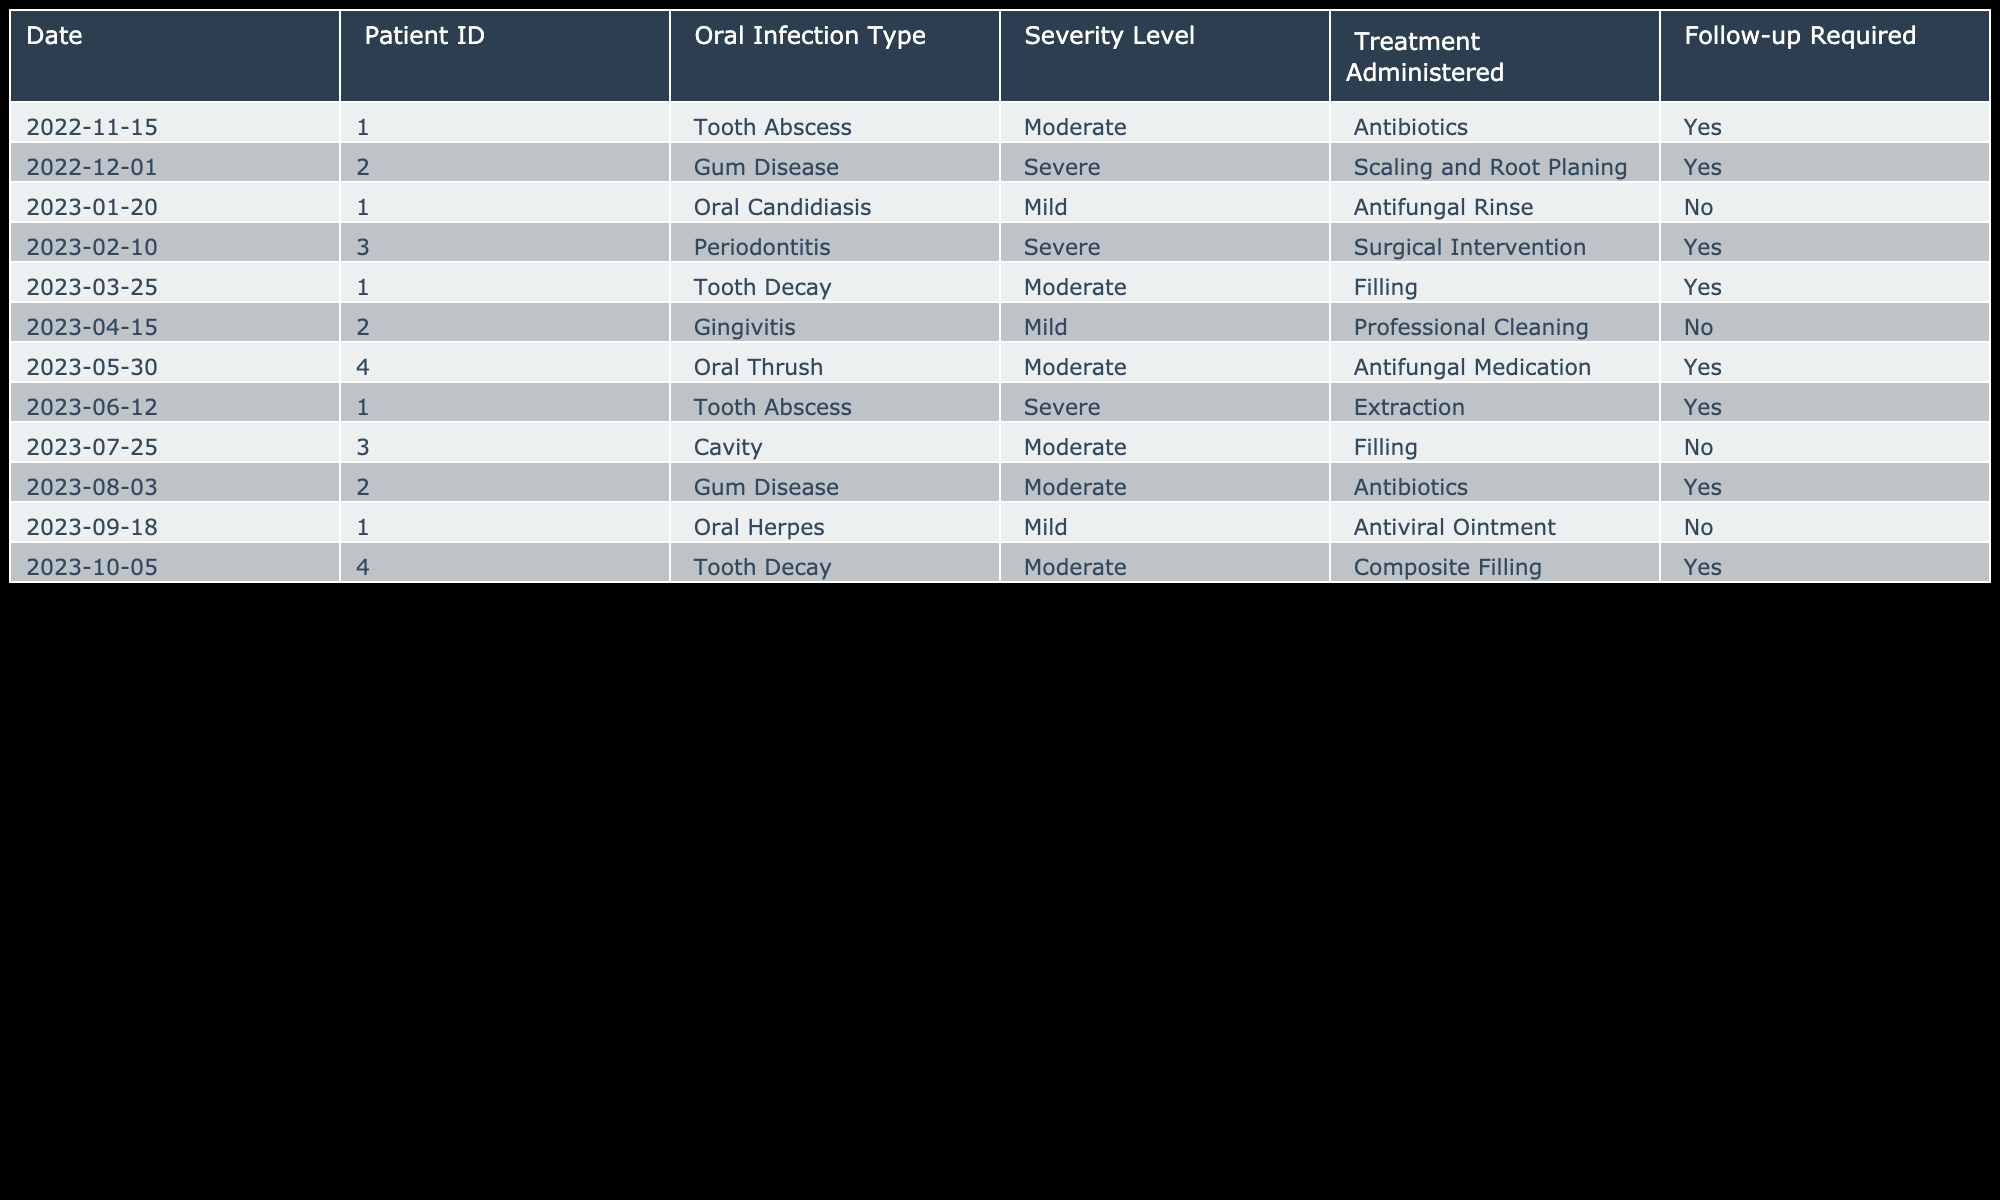What type of oral infection did Patient 001 have on March 25, 2023? The table shows that Patient 001 had Tooth Decay as the type of oral infection on that date.
Answer: Tooth Decay How many times did Patient 002 require follow-up treatment? From the table, Patient 002 was listed with two treatments: Gum Disease (Severe) and Gum Disease (Moderate), both of which required follow-ups. Therefore, there are two follow-ups required.
Answer: 2 What was the severity level of the oral infection for Patient 004 in October 2023? The table records that in October 2023, Patient 004 had a Tooth Decay infection with a severity level classified as Moderate.
Answer: Moderate Did Patient 003 require follow-up treatment for all oral infections? Evaluating the table for Patient 003, they had two treatments: one for Severe Periodontitis and one for a Moderate Cavity. The follow-up was required for the first treatment but not for the second, so the answer is no.
Answer: No What is the total number of Mild infections recorded in the table? The table lists three infections classified as Mild: Oral Candidiasis for Patient 001, Gingivitis for Patient 002, and Oral Herpes for Patient 001 again. Adding these, we find a total of three Mild infections.
Answer: 3 For which infection type did Patient 001 receive Extraction treatment, and what was its severity? The table indicates that Patient 001 received Extraction treatment for a Tooth Abscess classified as Severe. This can be identified from the entry for June 12, 2023.
Answer: Tooth Abscess, Severe Which patient had the highest severity level of infection, and what was it? Reviewing the table, Patient 002 had a Severe Gum Disease treatment, and Patient 003 had Severe Periodontitis treatment. However, since both are listed in the same severity level, they are equally the highest.
Answer: Patient 002 and Patient 003 had Severe infections How many infections were treated with antibiotics? By examining the table, Patient 002 had antibiotic treatment for Severe Gum Disease and Patient 002 had another infection treated with antibiotics for Moderate Gum Disease. Counting them gives a total of two infections treated with antibiotics.
Answer: 2 What was the follow-up status for Patient 004 on June 12, 2023? According to the table, Patient 004 did not require a follow-up for the treatment administered on June 12, 2023, as indicated next to their treatment details.
Answer: No 